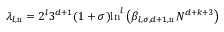Convert formula to latex. <formula><loc_0><loc_0><loc_500><loc_500>\lambda _ { l , u } = 2 ^ { l } 3 ^ { d + 1 } ( 1 + \sigma ) \ln ^ { l } \left ( \beta _ { l , \sigma , d + 1 , u } N ^ { d + k + 3 } \right )</formula> 